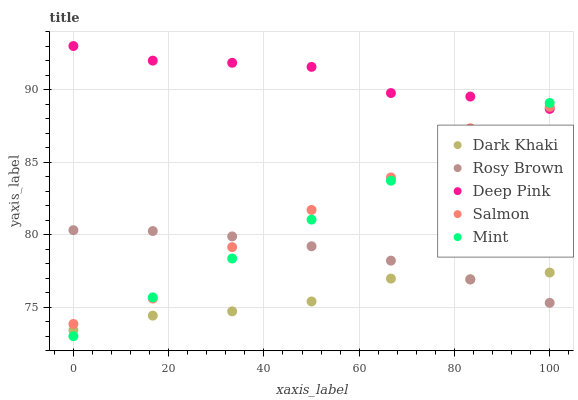Does Dark Khaki have the minimum area under the curve?
Answer yes or no. Yes. Does Deep Pink have the maximum area under the curve?
Answer yes or no. Yes. Does Mint have the minimum area under the curve?
Answer yes or no. No. Does Mint have the maximum area under the curve?
Answer yes or no. No. Is Mint the smoothest?
Answer yes or no. Yes. Is Salmon the roughest?
Answer yes or no. Yes. Is Rosy Brown the smoothest?
Answer yes or no. No. Is Rosy Brown the roughest?
Answer yes or no. No. Does Mint have the lowest value?
Answer yes or no. Yes. Does Rosy Brown have the lowest value?
Answer yes or no. No. Does Deep Pink have the highest value?
Answer yes or no. Yes. Does Mint have the highest value?
Answer yes or no. No. Is Rosy Brown less than Deep Pink?
Answer yes or no. Yes. Is Deep Pink greater than Rosy Brown?
Answer yes or no. Yes. Does Mint intersect Rosy Brown?
Answer yes or no. Yes. Is Mint less than Rosy Brown?
Answer yes or no. No. Is Mint greater than Rosy Brown?
Answer yes or no. No. Does Rosy Brown intersect Deep Pink?
Answer yes or no. No. 